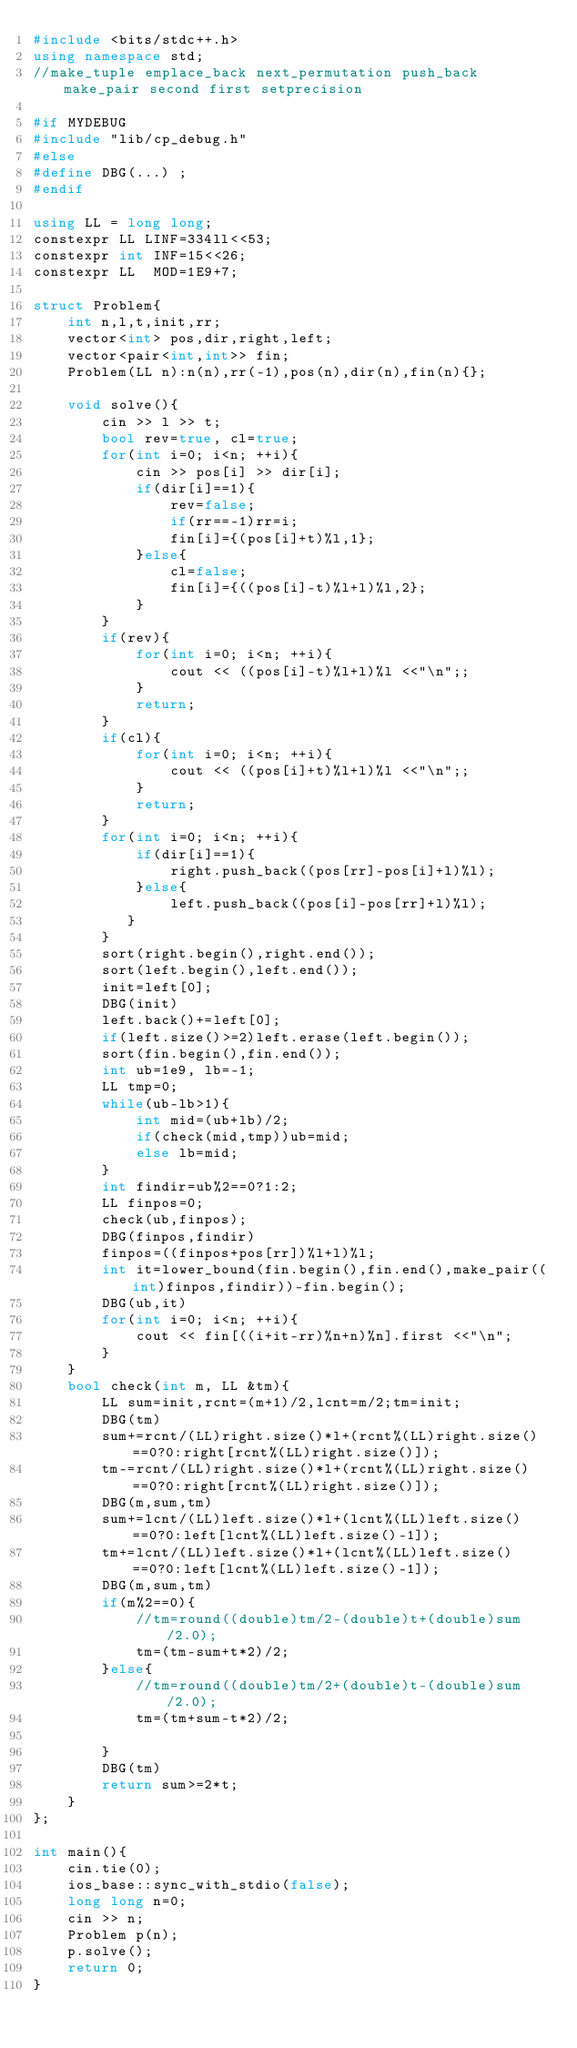Convert code to text. <code><loc_0><loc_0><loc_500><loc_500><_C++_>#include <bits/stdc++.h>
using namespace std;
//make_tuple emplace_back next_permutation push_back make_pair second first setprecision

#if MYDEBUG
#include "lib/cp_debug.h"
#else
#define DBG(...) ;
#endif

using LL = long long;
constexpr LL LINF=334ll<<53;
constexpr int INF=15<<26;
constexpr LL  MOD=1E9+7;

struct Problem{
    int n,l,t,init,rr;
    vector<int> pos,dir,right,left;
    vector<pair<int,int>> fin;
    Problem(LL n):n(n),rr(-1),pos(n),dir(n),fin(n){};

    void solve(){
        cin >> l >> t;
        bool rev=true, cl=true;
        for(int i=0; i<n; ++i){
            cin >> pos[i] >> dir[i];
            if(dir[i]==1){
                rev=false;
                if(rr==-1)rr=i;
                fin[i]={(pos[i]+t)%l,1};
            }else{
                cl=false;
                fin[i]={((pos[i]-t)%l+l)%l,2};
            }
        }
        if(rev){
            for(int i=0; i<n; ++i){
                cout << ((pos[i]-t)%l+l)%l <<"\n";;
            }
            return;
        }
        if(cl){
            for(int i=0; i<n; ++i){
                cout << ((pos[i]+t)%l+l)%l <<"\n";;
            }
            return;
        }
        for(int i=0; i<n; ++i){
            if(dir[i]==1){
                right.push_back((pos[rr]-pos[i]+l)%l);
            }else{
                left.push_back((pos[i]-pos[rr]+l)%l);
           }
        }
        sort(right.begin(),right.end());
        sort(left.begin(),left.end());
        init=left[0];
        DBG(init)
        left.back()+=left[0];
        if(left.size()>=2)left.erase(left.begin());
        sort(fin.begin(),fin.end());
        int ub=1e9, lb=-1;
        LL tmp=0;
        while(ub-lb>1){
            int mid=(ub+lb)/2;
            if(check(mid,tmp))ub=mid;
            else lb=mid;
        }
        int findir=ub%2==0?1:2;
        LL finpos=0;
        check(ub,finpos);
        DBG(finpos,findir)
        finpos=((finpos+pos[rr])%l+l)%l;
        int it=lower_bound(fin.begin(),fin.end(),make_pair((int)finpos,findir))-fin.begin();
        DBG(ub,it)
        for(int i=0; i<n; ++i){
            cout << fin[((i+it-rr)%n+n)%n].first <<"\n";
        }
    }
    bool check(int m, LL &tm){
        LL sum=init,rcnt=(m+1)/2,lcnt=m/2;tm=init;
        DBG(tm)
        sum+=rcnt/(LL)right.size()*l+(rcnt%(LL)right.size()==0?0:right[rcnt%(LL)right.size()]);
        tm-=rcnt/(LL)right.size()*l+(rcnt%(LL)right.size()==0?0:right[rcnt%(LL)right.size()]);
        DBG(m,sum,tm)
        sum+=lcnt/(LL)left.size()*l+(lcnt%(LL)left.size()==0?0:left[lcnt%(LL)left.size()-1]);
        tm+=lcnt/(LL)left.size()*l+(lcnt%(LL)left.size()==0?0:left[lcnt%(LL)left.size()-1]);
        DBG(m,sum,tm)
        if(m%2==0){
            //tm=round((double)tm/2-(double)t+(double)sum/2.0);
            tm=(tm-sum+t*2)/2;
        }else{
            //tm=round((double)tm/2+(double)t-(double)sum/2.0);
            tm=(tm+sum-t*2)/2;

        }
        DBG(tm)
        return sum>=2*t;
    }
};

int main(){
    cin.tie(0);
    ios_base::sync_with_stdio(false);
    long long n=0;
    cin >> n;
    Problem p(n);
    p.solve();
    return 0;
}

</code> 